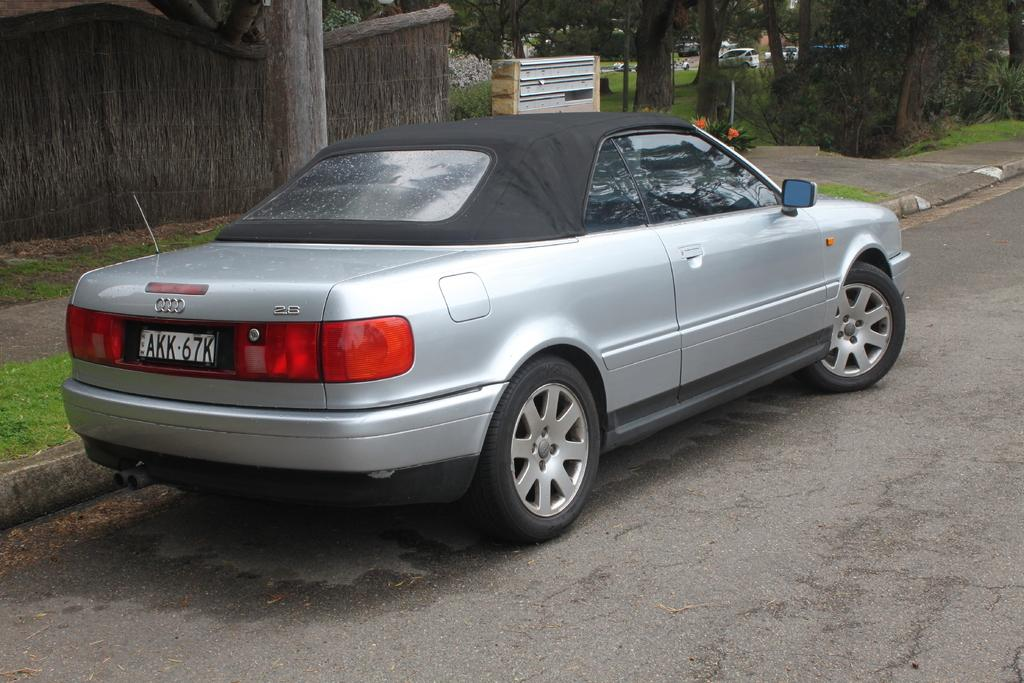What is the main subject in the foreground of the image? There is a car in the foreground of the image. Where is the car located? The car is on the road. What can be seen in the background of the image? There is a wall, a trunk, an object, and a side path in the background of the image. What type of government is depicted in the image? There is no depiction of a government in the image; it features a car on the road and various background elements. 